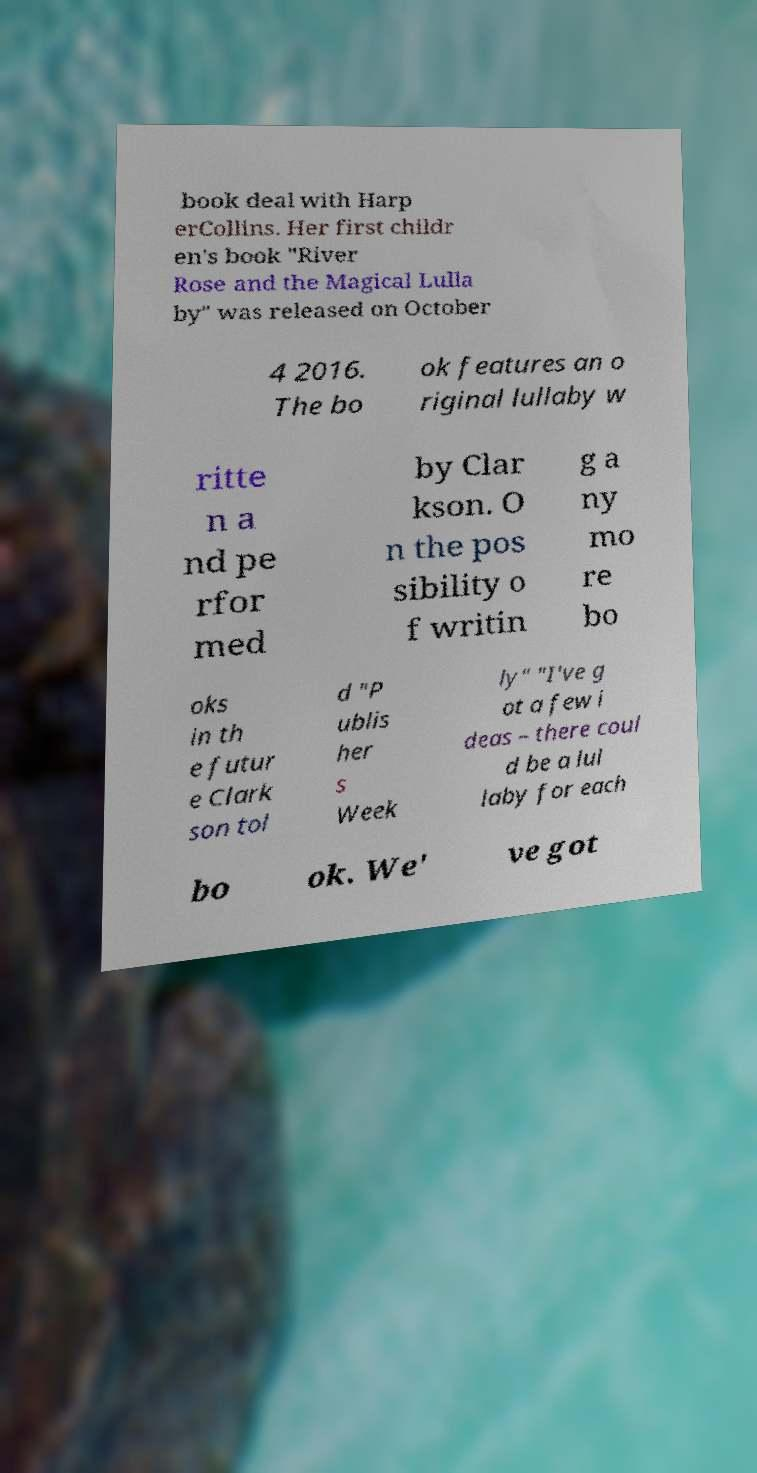Can you accurately transcribe the text from the provided image for me? book deal with Harp erCollins. Her first childr en's book "River Rose and the Magical Lulla by" was released on October 4 2016. The bo ok features an o riginal lullaby w ritte n a nd pe rfor med by Clar kson. O n the pos sibility o f writin g a ny mo re bo oks in th e futur e Clark son tol d "P ublis her s Week ly" "I've g ot a few i deas – there coul d be a lul laby for each bo ok. We' ve got 